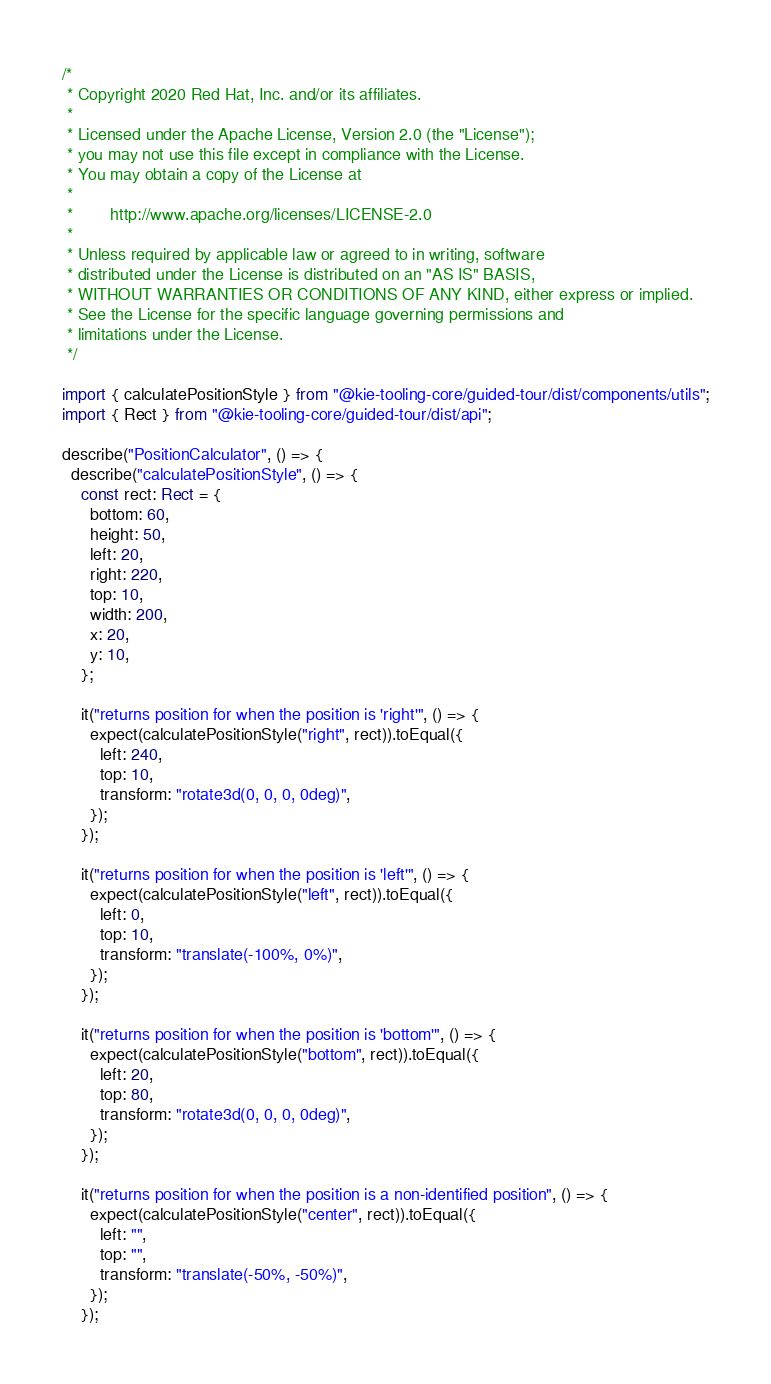Convert code to text. <code><loc_0><loc_0><loc_500><loc_500><_TypeScript_>/*
 * Copyright 2020 Red Hat, Inc. and/or its affiliates.
 *
 * Licensed under the Apache License, Version 2.0 (the "License");
 * you may not use this file except in compliance with the License.
 * You may obtain a copy of the License at
 *
 *        http://www.apache.org/licenses/LICENSE-2.0
 *
 * Unless required by applicable law or agreed to in writing, software
 * distributed under the License is distributed on an "AS IS" BASIS,
 * WITHOUT WARRANTIES OR CONDITIONS OF ANY KIND, either express or implied.
 * See the License for the specific language governing permissions and
 * limitations under the License.
 */

import { calculatePositionStyle } from "@kie-tooling-core/guided-tour/dist/components/utils";
import { Rect } from "@kie-tooling-core/guided-tour/dist/api";

describe("PositionCalculator", () => {
  describe("calculatePositionStyle", () => {
    const rect: Rect = {
      bottom: 60,
      height: 50,
      left: 20,
      right: 220,
      top: 10,
      width: 200,
      x: 20,
      y: 10,
    };

    it("returns position for when the position is 'right'", () => {
      expect(calculatePositionStyle("right", rect)).toEqual({
        left: 240,
        top: 10,
        transform: "rotate3d(0, 0, 0, 0deg)",
      });
    });

    it("returns position for when the position is 'left'", () => {
      expect(calculatePositionStyle("left", rect)).toEqual({
        left: 0,
        top: 10,
        transform: "translate(-100%, 0%)",
      });
    });

    it("returns position for when the position is 'bottom'", () => {
      expect(calculatePositionStyle("bottom", rect)).toEqual({
        left: 20,
        top: 80,
        transform: "rotate3d(0, 0, 0, 0deg)",
      });
    });

    it("returns position for when the position is a non-identified position", () => {
      expect(calculatePositionStyle("center", rect)).toEqual({
        left: "",
        top: "",
        transform: "translate(-50%, -50%)",
      });
    });
</code> 